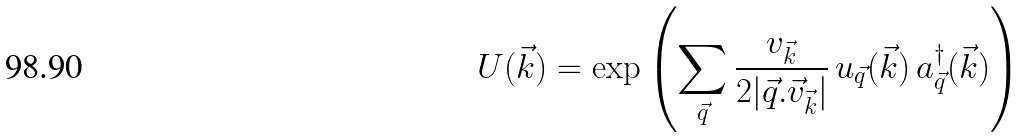Convert formula to latex. <formula><loc_0><loc_0><loc_500><loc_500>U ( \vec { k } ) = \exp \left ( \sum _ { \vec { q } } \frac { v _ { \vec { k } } } { 2 | \vec { q } . \vec { v } _ { \vec { k } } | } \, u _ { \vec { q } } ( \vec { k } ) \, a ^ { \dag } _ { \vec { q } } ( \vec { k } ) \right )</formula> 